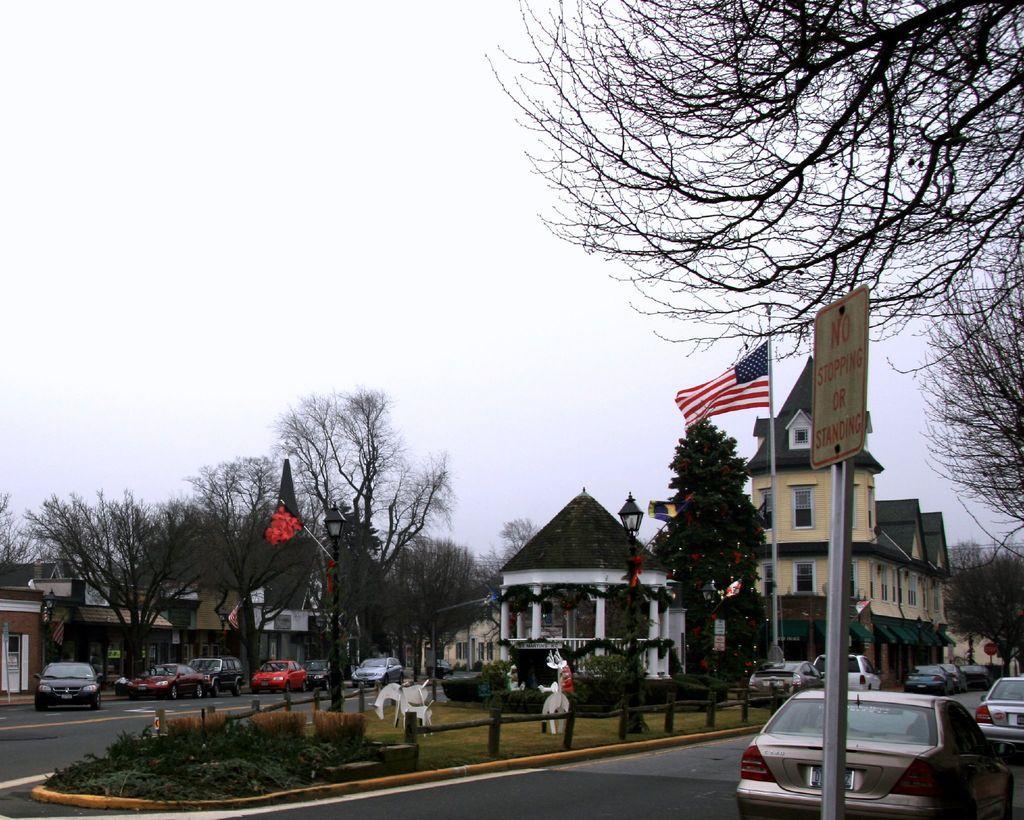In one or two sentences, can you explain what this image depicts? In this image I can see few vehicles on the road. Background I can see trees, buildings in white and cream color and sky in white color. 